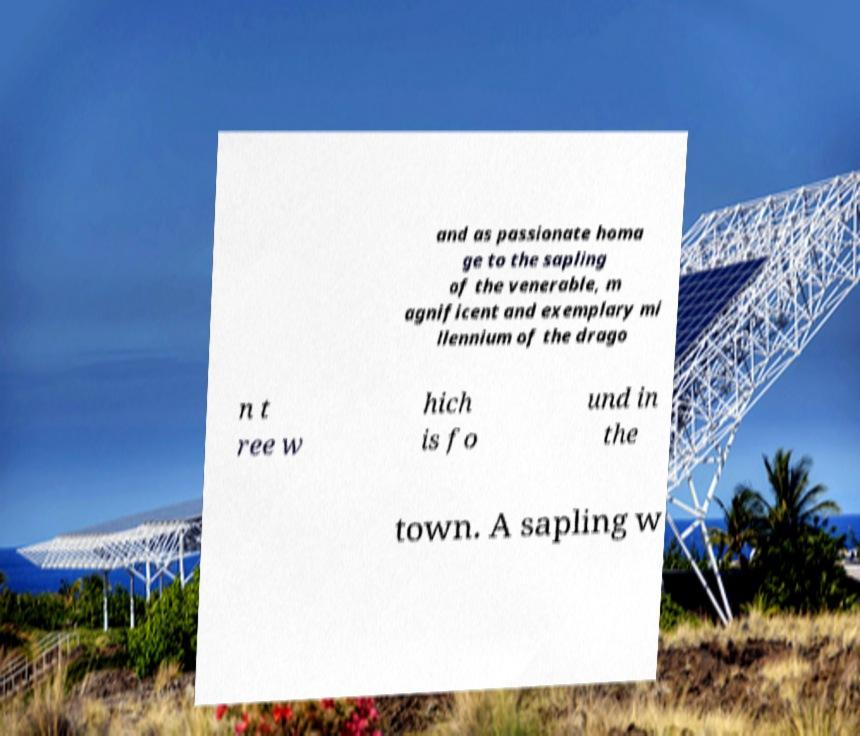Could you extract and type out the text from this image? and as passionate homa ge to the sapling of the venerable, m agnificent and exemplary mi llennium of the drago n t ree w hich is fo und in the town. A sapling w 